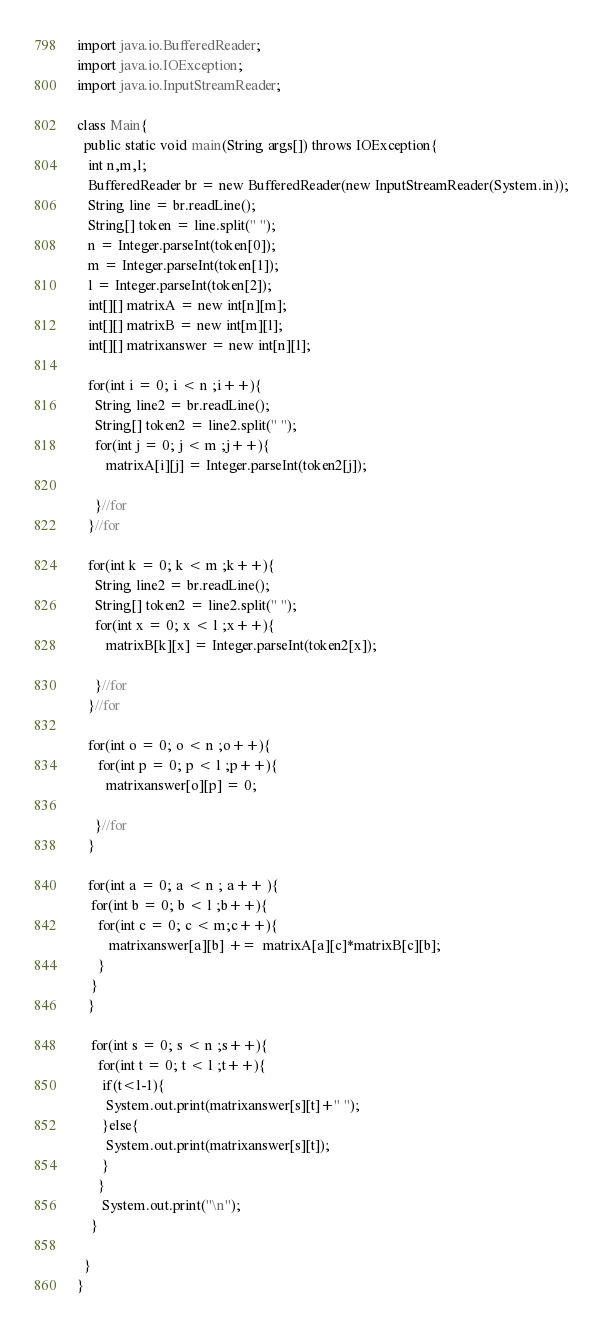Convert code to text. <code><loc_0><loc_0><loc_500><loc_500><_Java_>import java.io.BufferedReader;
import java.io.IOException;
import java.io.InputStreamReader;
 
class Main{
  public static void main(String args[]) throws IOException{
   int n,m,l;
   BufferedReader br = new BufferedReader(new InputStreamReader(System.in));
   String line = br.readLine(); 
   String[] token = line.split(" ");
   n = Integer.parseInt(token[0]);
   m = Integer.parseInt(token[1]);
   l = Integer.parseInt(token[2]); 
   int[][] matrixA = new int[n][m];
   int[][] matrixB = new int[m][l];
   int[][] matrixanswer = new int[n][l]; 
 
   for(int i = 0; i < n ;i++){
     String line2 = br.readLine(); 
     String[] token2 = line2.split(" ");
     for(int j = 0; j < m ;j++){
        matrixA[i][j] = Integer.parseInt(token2[j]);
         
     }//for  
   }//for
 
   for(int k = 0; k < m ;k++){
     String line2 = br.readLine(); 
     String[] token2 = line2.split(" ");
     for(int x = 0; x < l ;x++){
        matrixB[k][x] = Integer.parseInt(token2[x]);
         
     }//for  
   }//for
 
   for(int o = 0; o < n ;o++){
      for(int p = 0; p < l ;p++){
        matrixanswer[o][p] = 0;
         
     }//for 
   }   
 
   for(int a = 0; a < n ; a++ ){
    for(int b = 0; b < l ;b++){
      for(int c = 0; c < m;c++){ 
         matrixanswer[a][b] +=  matrixA[a][c]*matrixB[c][b]; 
      } 
    }
   }   

    for(int s = 0; s < n ;s++){
      for(int t = 0; t < l ;t++){
       if(t<l-1){ 
        System.out.print(matrixanswer[s][t]+" ");
       }else{
        System.out.print(matrixanswer[s][t]);
       }
      }
       System.out.print("\n"); 
    }
 
  }
}</code> 